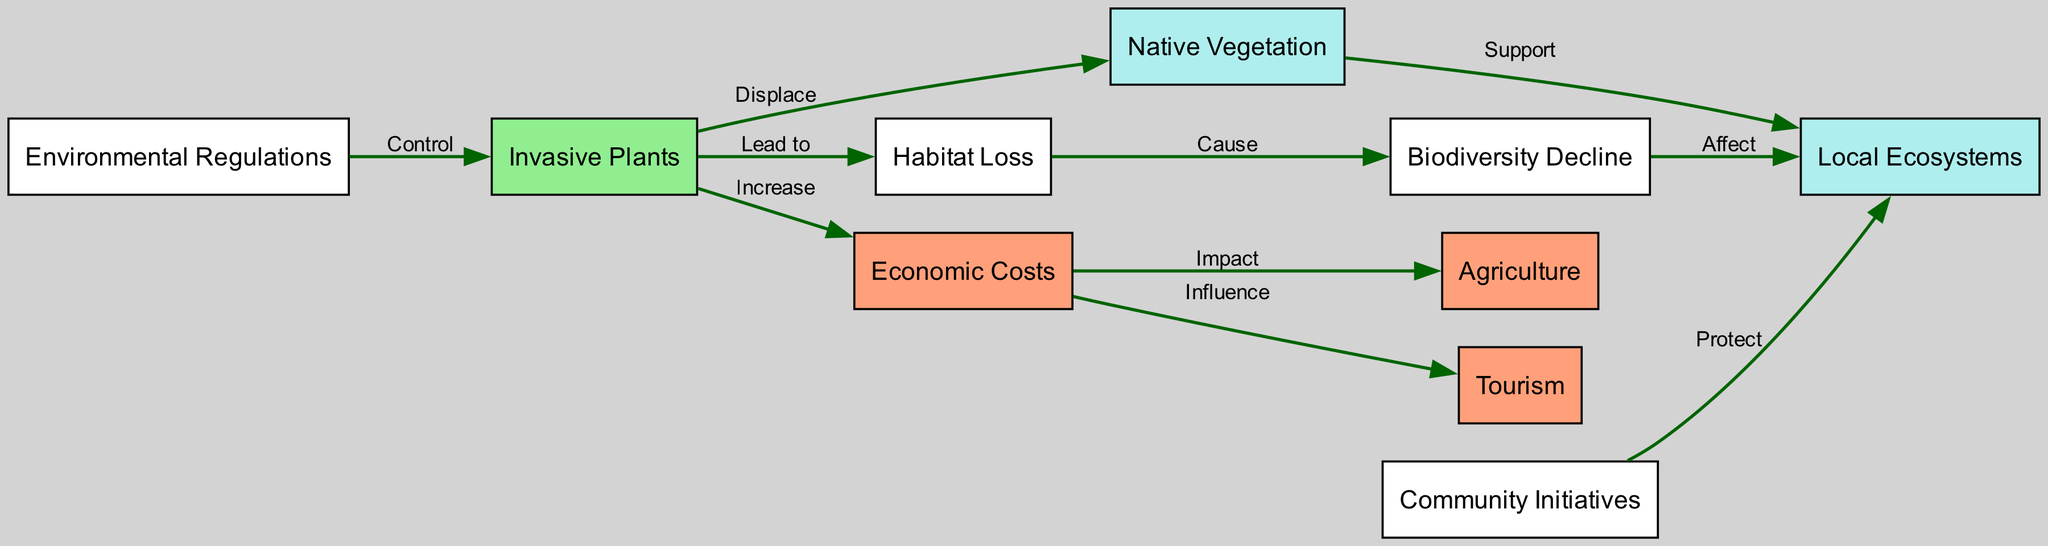What node is displaced by invasive plants? According to the diagram, invasive plants directly connect to native vegetation with the label "Displace." This indicates that invasive plants cause a displacement effect on native vegetation.
Answer: Native Vegetation How many edges are connected to economic costs? By counting the edges originating from the economic costs node, we see that it has two connections: one to agriculture and another to tourism. This shows the direct influence of economic costs on both sectors.
Answer: 2 What causes biodiversity decline? The flow of the diagram shows that habitat loss leads to biodiversity decline. The relationship is depicted clearly with the label "Cause" connecting these two nodes.
Answer: Habitat Loss Which initiative protects local ecosystems? The diagram shows that community initiatives have a direct connection to local ecosystems and are labeled "Protect." This indicates their role in safeguarding those ecosystems.
Answer: Community Initiatives What do environmental regulations control? The diagram indicates that environmental regulations have a control relationship with invasive plants. This suggests that regulations are aimed at managing or mitigating the impact of invasive plants.
Answer: Invasive Plants How do invasive plants affect economic costs? The diagram clearly states that invasive plants increase economic costs, establishing a direct connection labeled "Increase." This implies a negative economic impact stemming from the presence of invasive plants.
Answer: Increase What leads to habitat loss? The diagram connects invasive plants to habitat loss with the label "Lead to." This clearly indicates that the introduction and spread of invasive plants are responsible for the loss of habitat.
Answer: Invasive Plants Which sector is influenced by economic costs? From the edges connected to economic costs, we see that tourism is explicitly labeled as being influenced by it, indicating a financial relationship affected by economic factors.
Answer: Tourism How does biodiversity decline affect local ecosystems? The diagram shows a connection from biodiversity decline to local ecosystems with the label "Affect." This indicates that a decline in biodiversity has a direct negative impact on the well-being of local ecosystems.
Answer: Affect 